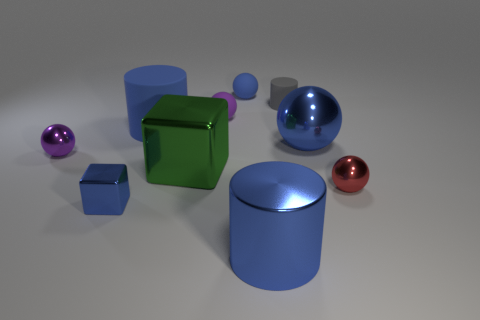What color is the matte cylinder that is the same size as the blue block? gray 